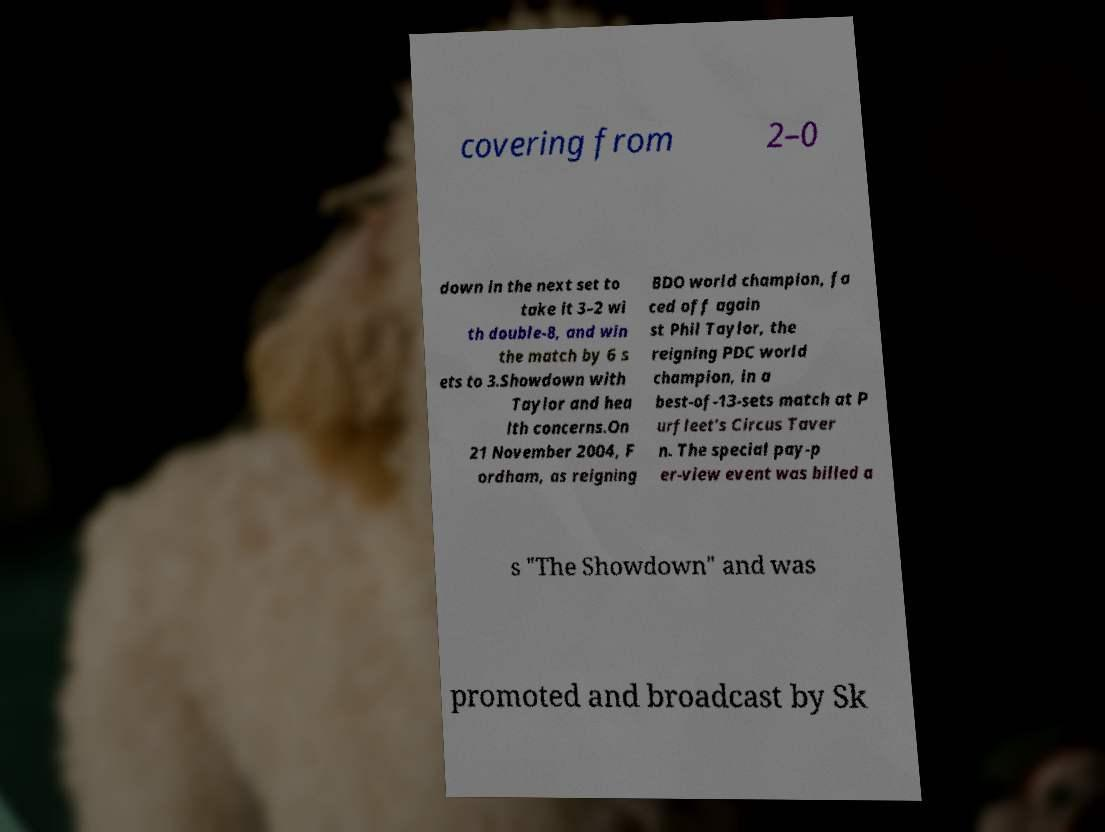Please read and relay the text visible in this image. What does it say? covering from 2–0 down in the next set to take it 3–2 wi th double-8, and win the match by 6 s ets to 3.Showdown with Taylor and hea lth concerns.On 21 November 2004, F ordham, as reigning BDO world champion, fa ced off again st Phil Taylor, the reigning PDC world champion, in a best-of-13-sets match at P urfleet's Circus Taver n. The special pay-p er-view event was billed a s "The Showdown" and was promoted and broadcast by Sk 